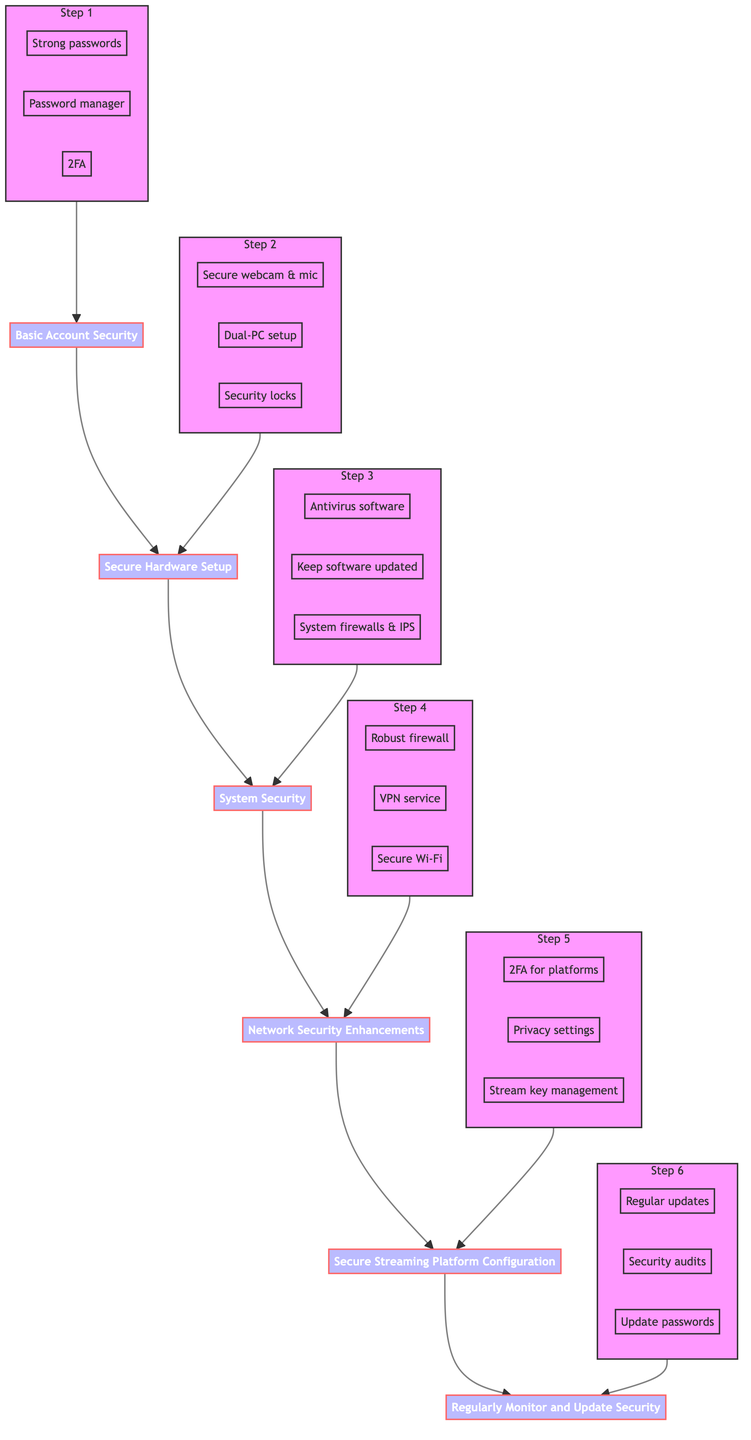What is the first step in the flow chart? The first step in the flow chart is labeled "Basic Account Security." It is the bottommost node in the flow chart and serves as the foundation for the setup process.
Answer: Basic Account Security How many main steps are there in the diagram? The diagram consists of a total of six main steps, as indicated by the six nodes from the first to the last step.
Answer: Six What is the last step in the flow chart? The last step in the flow chart is labeled "Regularly Monitor and Update Security," which is the topmost node in the flow representing the last instruction to follow.
Answer: Regularly Monitor and Update Security What are the three details listed under "System Security"? The details listed under "System Security" are: "Install antivirus software," "Keep all software updated," and "Enable and configure system firewalls and intrusion prevention systems."
Answer: Install antivirus software, Keep all software updated, Enable and configure system firewalls and intrusion prevention systems What does the step "Secure Hardware Setup" focus on? "Secure Hardware Setup" focuses on the physical security of streaming equipment and setup. It emphasizes using high-quality devices, employing a dual-PC setup, and installing physical security measures on devices.
Answer: Secure Hardware Setup focuses on physical security of equipment How many details are included in "Secure Streaming Platform Configuration"? There are three details included in "Secure Streaming Platform Configuration": "Enable 2FA for all streaming platform accounts," "Set privacy settings," and "Establish stream key management practices."
Answer: Three Which step directly precedes "Network Security Enhancements"? "Secure Hardware Setup" directly precedes "Network Security Enhancements" in the flow chart, indicating the order of setup processes.
Answer: Secure Hardware Setup What is required for "Basic Account Security"? The requirements for "Basic Account Security" include creating strong passwords, using a password manager, and enabling Two-Factor Authentication. These are fundamental actions needed to secure accounts.
Answer: Strong passwords, password manager, Two-Factor Authentication What improves security in "Network Security Enhancements"? "Network Security Enhancements" are improved through robust firewall solutions, using a VPN service, and setting up a secure Wi-Fi network. Each of these actions enhances the security of the network used for streaming.
Answer: Robust firewall solutions, VPN service, secure Wi-Fi network 